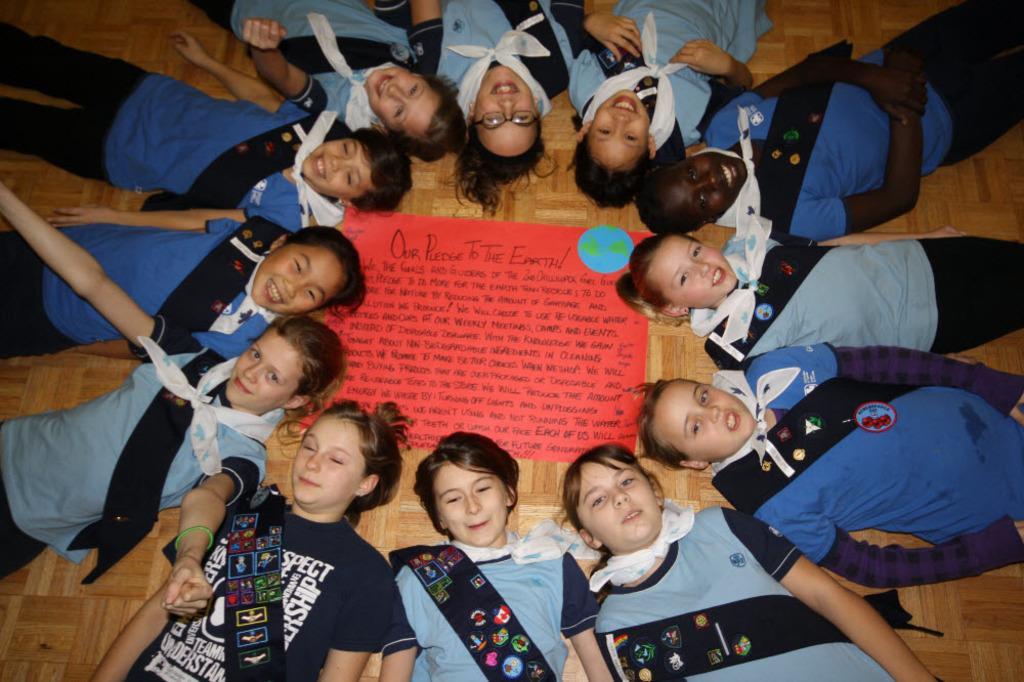Could you give a brief overview of what you see in this image? In this image we can see a group of people lying on the surface, hanging a cloth around their neck. Some people are holding their heads on a chart on which some text written on it. 